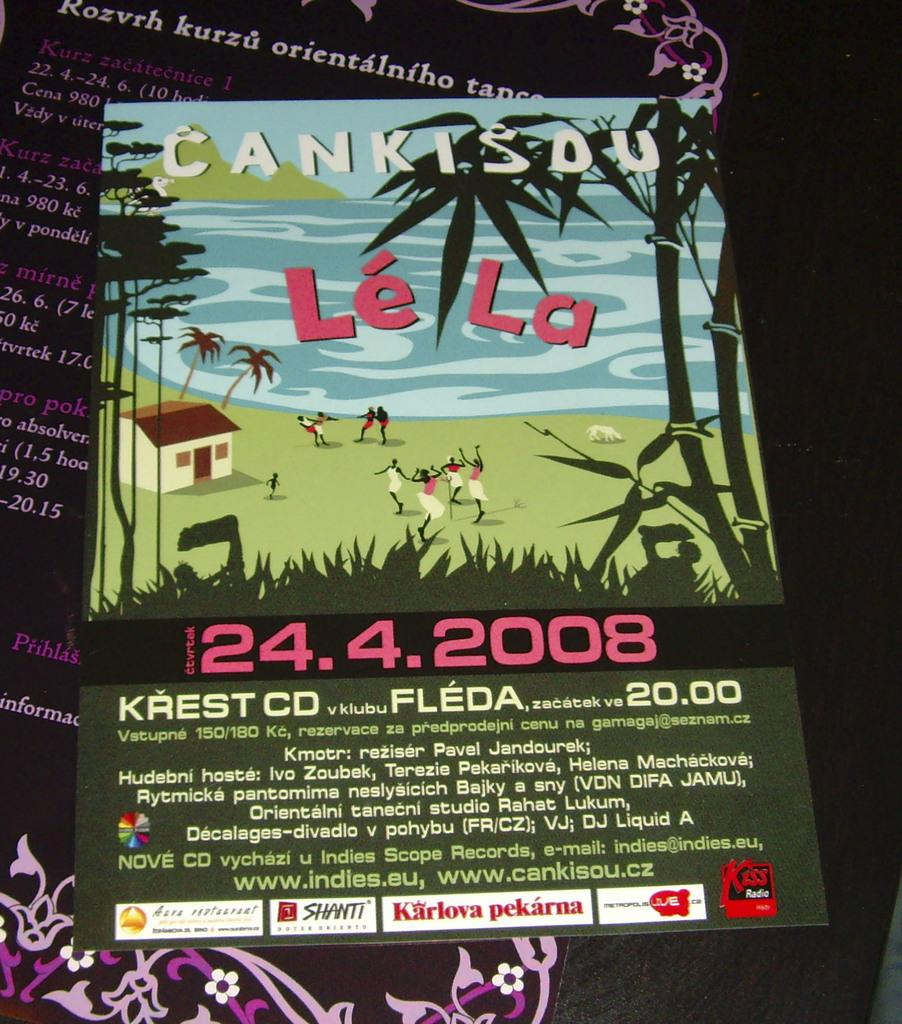<image>
Give a short and clear explanation of the subsequent image. A poster advertises an event which took place on 4/24/2008. 